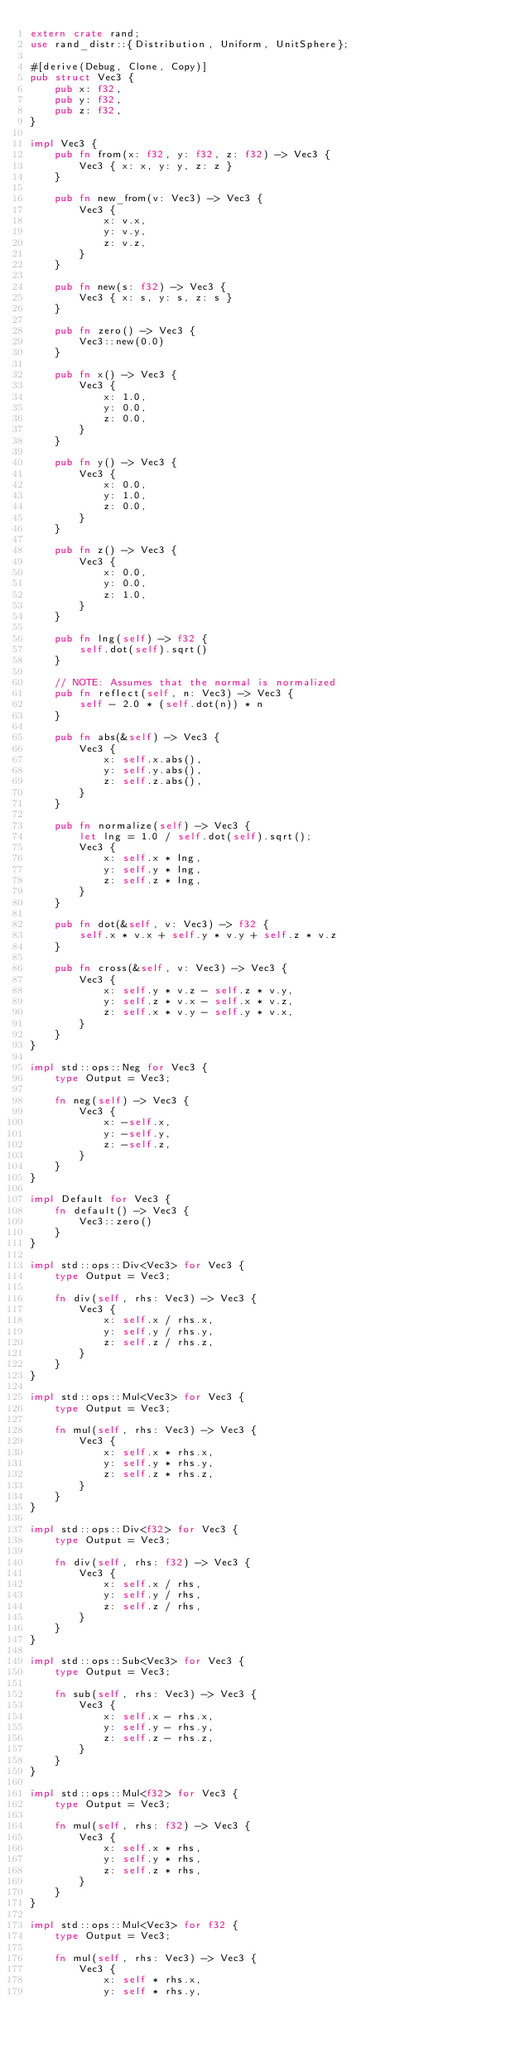Convert code to text. <code><loc_0><loc_0><loc_500><loc_500><_Rust_>extern crate rand;
use rand_distr::{Distribution, Uniform, UnitSphere};

#[derive(Debug, Clone, Copy)]
pub struct Vec3 {
    pub x: f32,
    pub y: f32,
    pub z: f32,
}

impl Vec3 {
    pub fn from(x: f32, y: f32, z: f32) -> Vec3 {
        Vec3 { x: x, y: y, z: z }
    }

    pub fn new_from(v: Vec3) -> Vec3 {
        Vec3 {
            x: v.x,
            y: v.y,
            z: v.z,
        }
    }

    pub fn new(s: f32) -> Vec3 {
        Vec3 { x: s, y: s, z: s }
    }

    pub fn zero() -> Vec3 {
        Vec3::new(0.0)
    }

    pub fn x() -> Vec3 {
        Vec3 {
            x: 1.0,
            y: 0.0,
            z: 0.0,
        }
    }

    pub fn y() -> Vec3 {
        Vec3 {
            x: 0.0,
            y: 1.0,
            z: 0.0,
        }
    }

    pub fn z() -> Vec3 {
        Vec3 {
            x: 0.0,
            y: 0.0,
            z: 1.0,
        }
    }

    pub fn lng(self) -> f32 {
        self.dot(self).sqrt()
    }

    // NOTE: Assumes that the normal is normalized
    pub fn reflect(self, n: Vec3) -> Vec3 {
        self - 2.0 * (self.dot(n)) * n
    }

    pub fn abs(&self) -> Vec3 {
        Vec3 {
            x: self.x.abs(),
            y: self.y.abs(),
            z: self.z.abs(),
        }
    }

    pub fn normalize(self) -> Vec3 {
        let lng = 1.0 / self.dot(self).sqrt();
        Vec3 {
            x: self.x * lng,
            y: self.y * lng,
            z: self.z * lng,
        }
    }

    pub fn dot(&self, v: Vec3) -> f32 {
        self.x * v.x + self.y * v.y + self.z * v.z
    }

    pub fn cross(&self, v: Vec3) -> Vec3 {
        Vec3 {
            x: self.y * v.z - self.z * v.y,
            y: self.z * v.x - self.x * v.z,
            z: self.x * v.y - self.y * v.x,
        }
    }
}

impl std::ops::Neg for Vec3 {
    type Output = Vec3;

    fn neg(self) -> Vec3 {
        Vec3 {
            x: -self.x,
            y: -self.y,
            z: -self.z,
        }
    }
}

impl Default for Vec3 {
    fn default() -> Vec3 {
        Vec3::zero()
    }
}

impl std::ops::Div<Vec3> for Vec3 {
    type Output = Vec3;

    fn div(self, rhs: Vec3) -> Vec3 {
        Vec3 {
            x: self.x / rhs.x,
            y: self.y / rhs.y,
            z: self.z / rhs.z,
        }
    }
}

impl std::ops::Mul<Vec3> for Vec3 {
    type Output = Vec3;

    fn mul(self, rhs: Vec3) -> Vec3 {
        Vec3 {
            x: self.x * rhs.x,
            y: self.y * rhs.y,
            z: self.z * rhs.z,
        }
    }
}

impl std::ops::Div<f32> for Vec3 {
    type Output = Vec3;

    fn div(self, rhs: f32) -> Vec3 {
        Vec3 {
            x: self.x / rhs,
            y: self.y / rhs,
            z: self.z / rhs,
        }
    }
}

impl std::ops::Sub<Vec3> for Vec3 {
    type Output = Vec3;

    fn sub(self, rhs: Vec3) -> Vec3 {
        Vec3 {
            x: self.x - rhs.x,
            y: self.y - rhs.y,
            z: self.z - rhs.z,
        }
    }
}

impl std::ops::Mul<f32> for Vec3 {
    type Output = Vec3;

    fn mul(self, rhs: f32) -> Vec3 {
        Vec3 {
            x: self.x * rhs,
            y: self.y * rhs,
            z: self.z * rhs,
        }
    }
}

impl std::ops::Mul<Vec3> for f32 {
    type Output = Vec3;

    fn mul(self, rhs: Vec3) -> Vec3 {
        Vec3 {
            x: self * rhs.x,
            y: self * rhs.y,</code> 